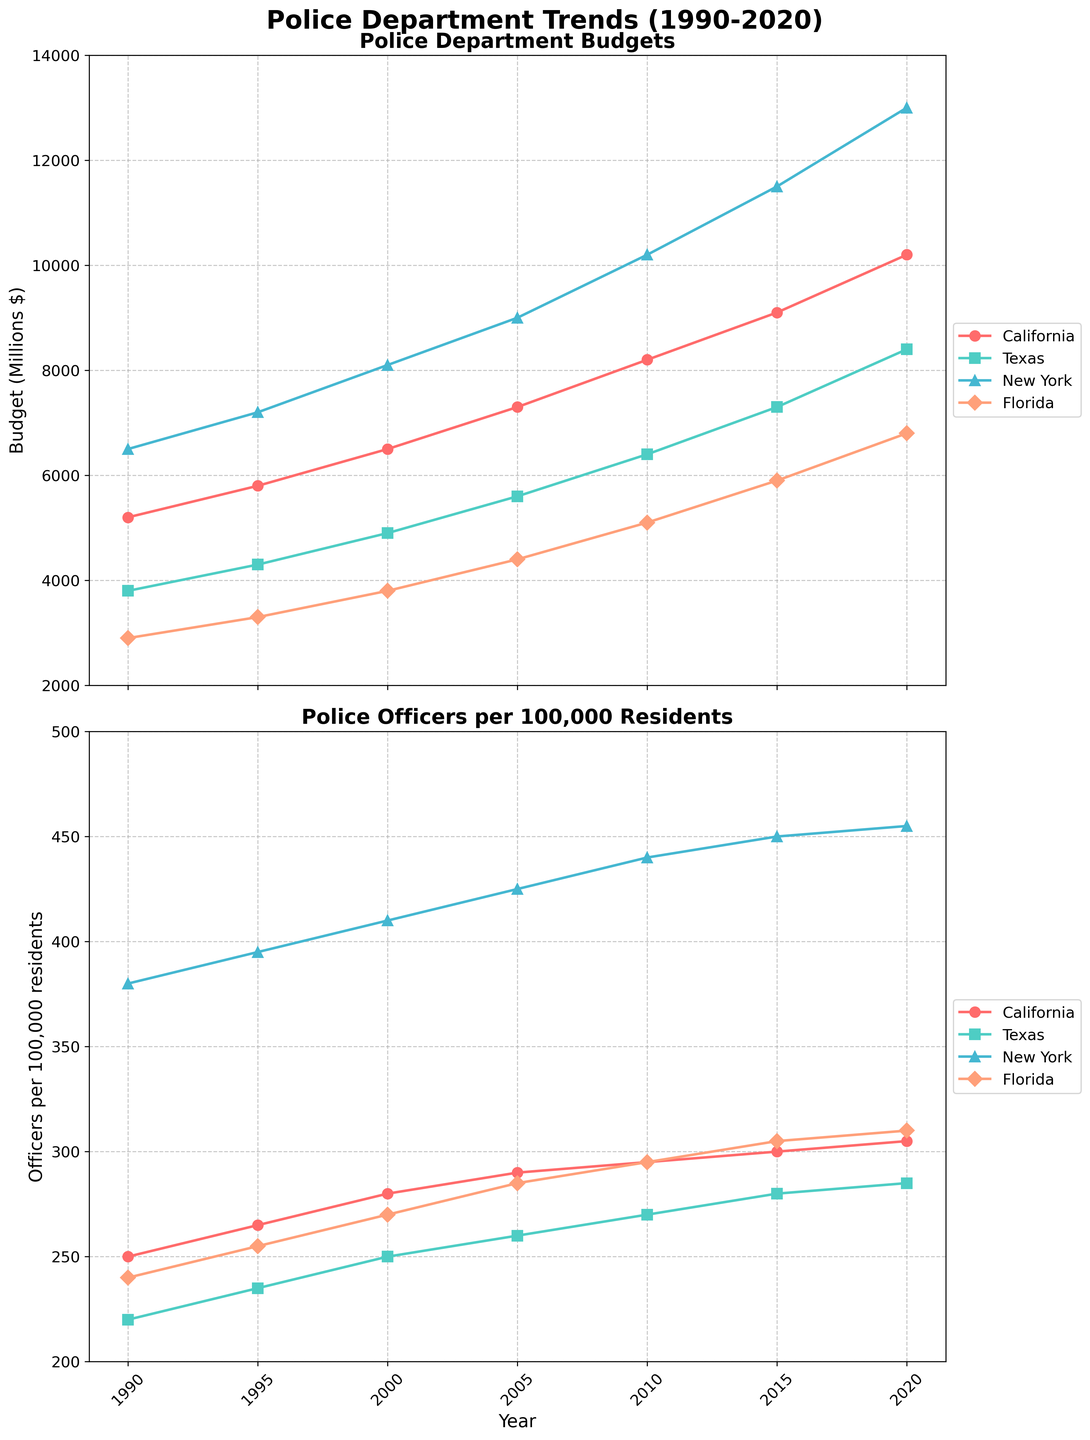What trend do you notice in California's police budget from 1990 to 2020? The data for California's police budget shows a steady increase from 1990 ($5200 million) to 2020 ($10200 million). By observing the plot, the budget grows consistently over the entire period.
Answer: A steady increase How does the number of police officers per 100k in New York in 2010 compare to that in Texas in 2020? In 2010, New York had 440 officers per 100k, while in Texas in 2020, the number was 285 officers per 100k. By comparing these numbers, New York had significantly more officers per 100k residents in 2010 than Texas in 2020.
Answer: New York had more Which state had the highest police budget in 2000? By examining the plot for the year 2000, New York had the highest police budget at $8100 million.
Answer: New York What is the average number of police officers per 100k in Florida between 1990 and 2020? The numbers for Florida from 1990 to 2020 are 240, 255, 270, 285, 295, 305, and 310. Adding these numbers: 240 + 255 + 270 + 285 + 295 + 305 + 310 = 1960. There are 7 data points, so the average is 1960 / 7 ≈ 280.
Answer: 280 Between California and Florida, which state saw a larger increase in the number of police officers per 100k from 1990 to 2020? In 1990, California had 250 officers per 100k, increasing to 305 in 2020, resulting in an increase of 55 officers. In Florida, the number increased from 240 to 310, resulting in an increase of 70 officers. Therefore, Florida saw a larger increase.
Answer: Florida What was the police budget for Texas in 2015, and how does it compare to California's budget in the same year? In 2015, Texas had a police budget of $7300 million, while California's budget was $9100 million. California's budget was $1800 million higher than Texas's.
Answer: California's budget was higher by $1800 million In which decade did New York see the largest increase in the number of police officers per 100k? By examining the trends, New York's largest increase occurred between 1990 (380 officers per 100k) and 2000 (410 officers per 100k), a 30 officer increase. The increases in other decades were smaller.
Answer: 1990 to 2000 If the police budgets for California and Texas doubled from 1990 to 2020, what were their respective budgets in 2020? The police budget for California in 1990 was $5200 million. If it doubled, it would be $10400 million. However, the actual budget in 2020 is $10200 million, slightly less than doubled. Texas in 1990 had a $3800 million budget, so doubling it would be $7600 million. Texas's actual 2020 budget was $8400 million, more than doubled.
Answer: California: $10200 million, Texas: $8400 million Which state's police budget grew the least from 1990 to 2020? The growth for each state is calculated by subtracting the 1990 budget from the 2020 budget. California grew by $10200 million - $5200 million = $5000 million, Texas by $8400 million - $3800 million = $4600 million, New York by $13000 million - $6500 million = $6500 million, and Florida by $6800 million - $2900 million = $3900 million. Florida's budget grew the least.
Answer: Florida 